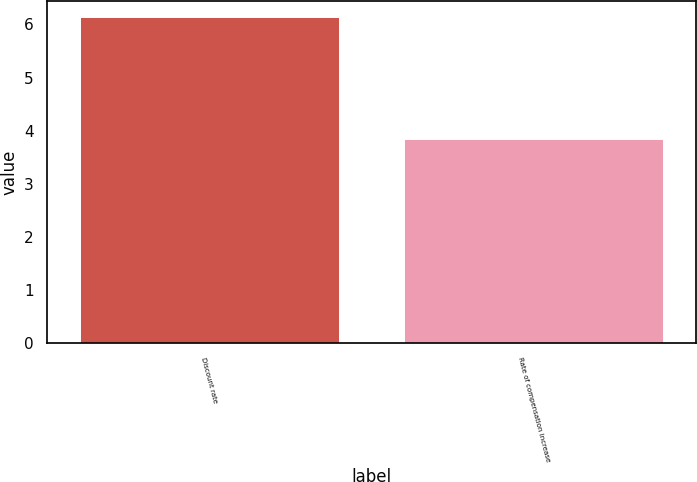Convert chart. <chart><loc_0><loc_0><loc_500><loc_500><bar_chart><fcel>Discount rate<fcel>Rate of compensation increase<nl><fcel>6.14<fcel>3.84<nl></chart> 